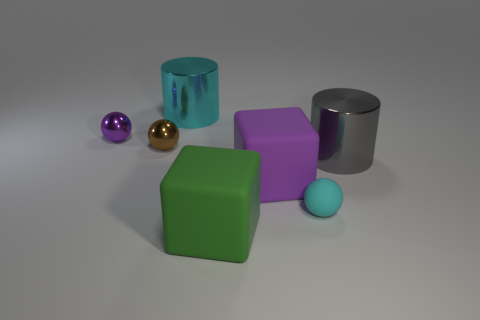Subtract all metal balls. How many balls are left? 1 Subtract all cyan cylinders. How many cylinders are left? 1 Add 1 gray metal cylinders. How many objects exist? 8 Subtract all cylinders. How many objects are left? 5 Subtract all large cyan things. Subtract all big brown rubber cylinders. How many objects are left? 6 Add 2 tiny brown metallic spheres. How many tiny brown metallic spheres are left? 3 Add 5 big cyan things. How many big cyan things exist? 6 Subtract 1 brown spheres. How many objects are left? 6 Subtract all gray spheres. Subtract all red cylinders. How many spheres are left? 3 